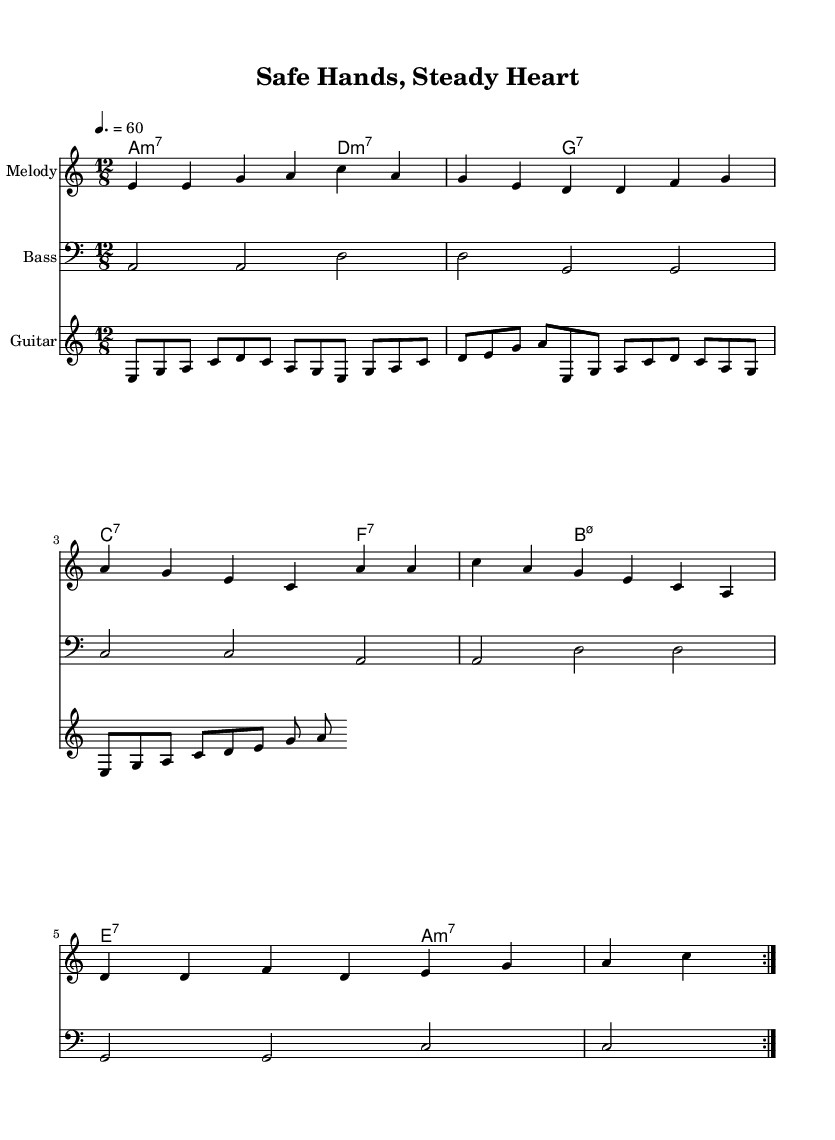What is the key signature of this music? The key signature is A minor, which is indicated by the absence of sharps or flats and occurs at the beginning of the staff.
Answer: A minor What is the time signature of this music? The time signature shown at the beginning of the staff is 12/8, indicating a compound time feel that divides each beat into three eighth notes.
Answer: 12/8 What is the tempo marking for this piece? The tempo marking indicates a speed of 60 beats per minute, specified as "4. = 60", meaning a quarter note is valued at 60 beats per minute.
Answer: 60 How many measures are in the repeated sections of the melody? The melody section contains 8 measures that are repeated, as shown by the repeat volta notation which appears after the first four measures.
Answer: 8 What chords are primarily used in the harmonies section? The primary chords featured in the harmonies are minor and dominant seventh chords, specifically A minor 7, D minor 7, G7, and C7 among others, which are characteristic of blues music.
Answer: Minor and dominant seventh chords What is the main theme conveyed in the lyrics? The lyrics emphasize gun safety and proper training, highlighting the responsibilities tied to handling firearms and the importance of establishing a safe practice.
Answer: Gun safety and proper training What does the guitar riff contribute to the overall feel of the piece? The guitar riff contributes a rhythmic and melodic texture that aligns with the blues feel, providing embellishments and reinforcing the themes in the lyrics while supporting the harmonic structure of the piece.
Answer: Rhythmic and melodic texture 